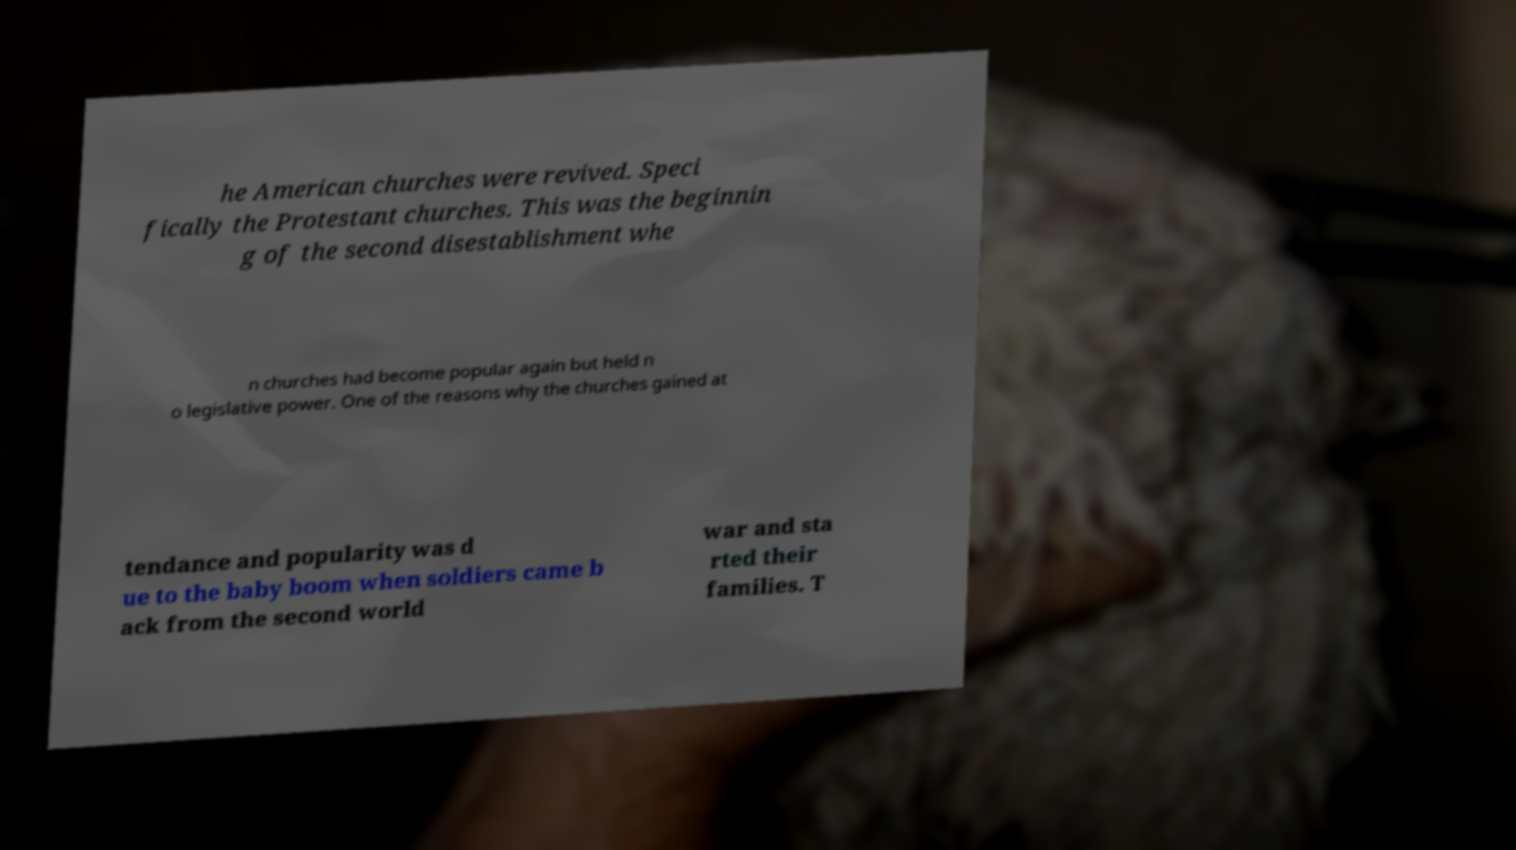For documentation purposes, I need the text within this image transcribed. Could you provide that? he American churches were revived. Speci fically the Protestant churches. This was the beginnin g of the second disestablishment whe n churches had become popular again but held n o legislative power. One of the reasons why the churches gained at tendance and popularity was d ue to the baby boom when soldiers came b ack from the second world war and sta rted their families. T 